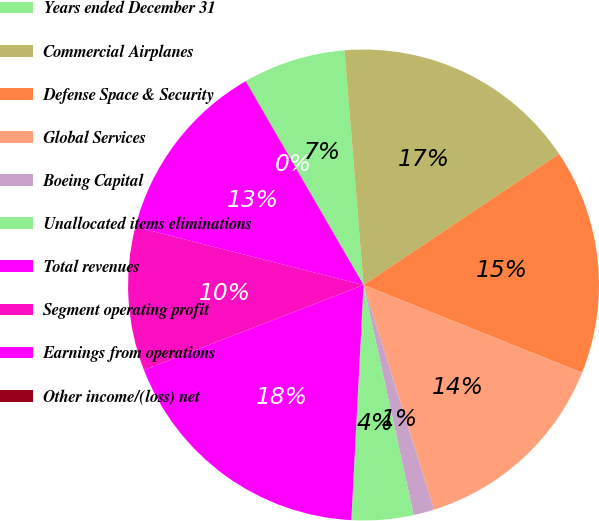Convert chart. <chart><loc_0><loc_0><loc_500><loc_500><pie_chart><fcel>Years ended December 31<fcel>Commercial Airplanes<fcel>Defense Space & Security<fcel>Global Services<fcel>Boeing Capital<fcel>Unallocated items eliminations<fcel>Total revenues<fcel>Segment operating profit<fcel>Earnings from operations<fcel>Other income/(loss) net<nl><fcel>7.05%<fcel>16.89%<fcel>15.48%<fcel>14.08%<fcel>1.43%<fcel>4.24%<fcel>18.29%<fcel>9.86%<fcel>12.67%<fcel>0.02%<nl></chart> 